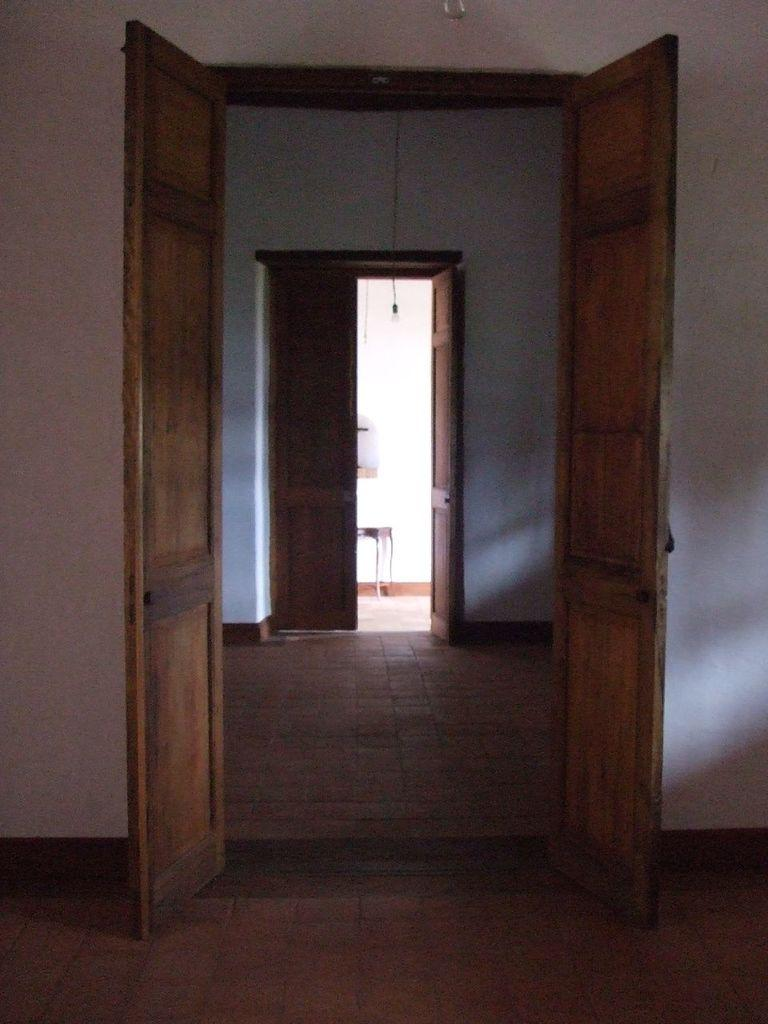What type of doors are present in the rooms in the image? The rooms have wooden doors. What color are the walls in the rooms? The walls in the rooms are white. Can you describe the furniture in the image? There is a table in the background. Where is the table located in relation to the white wall? The table is near a white wall. What type of rail can be seen in the image? There is no rail present in the image. What direction is the current flowing in the image? There is no current present in the image. 